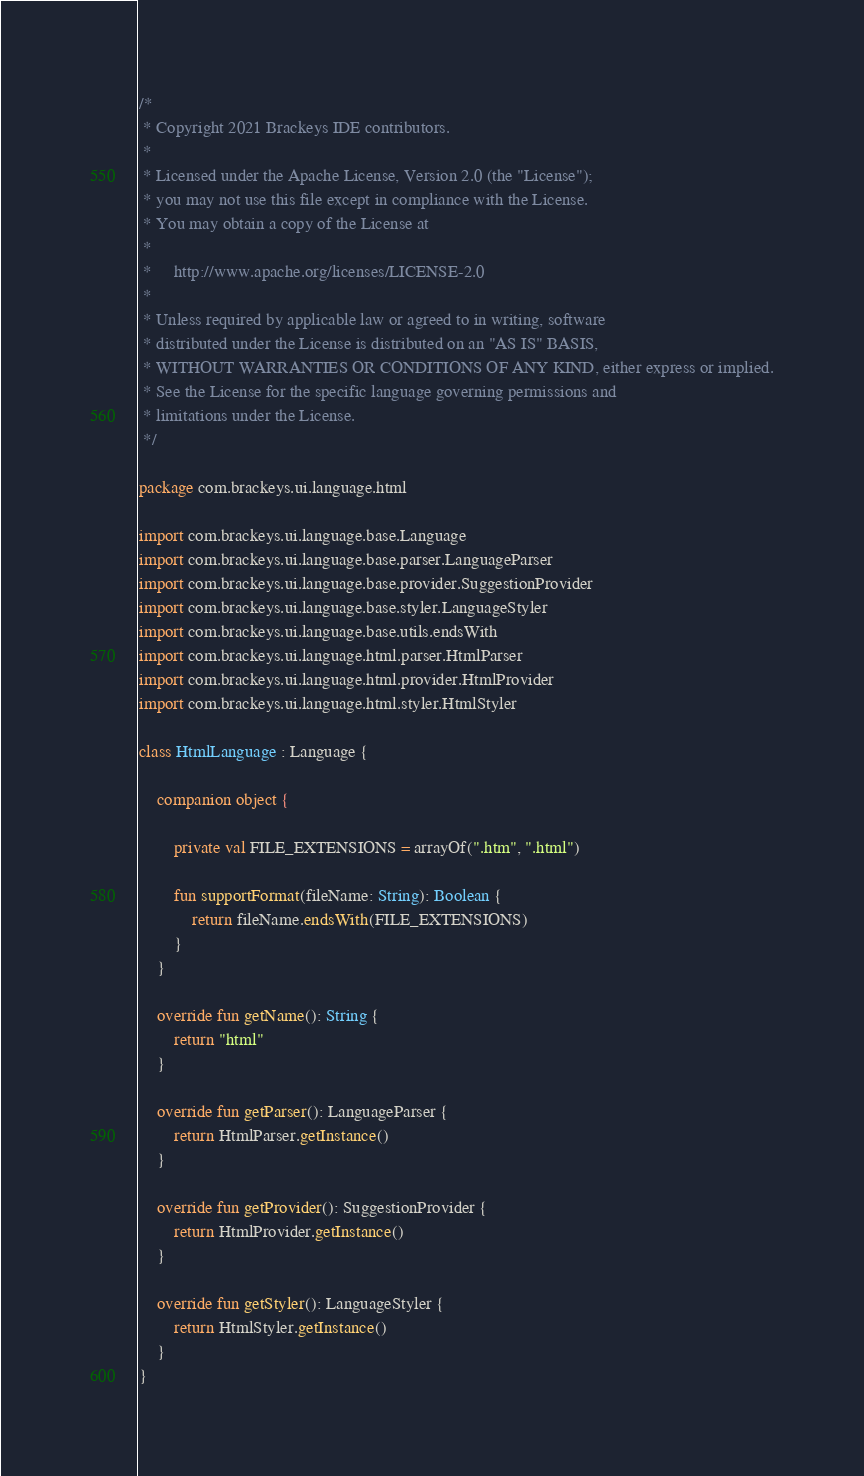Convert code to text. <code><loc_0><loc_0><loc_500><loc_500><_Kotlin_>/*
 * Copyright 2021 Brackeys IDE contributors.
 *
 * Licensed under the Apache License, Version 2.0 (the "License");
 * you may not use this file except in compliance with the License.
 * You may obtain a copy of the License at
 *
 *     http://www.apache.org/licenses/LICENSE-2.0
 *
 * Unless required by applicable law or agreed to in writing, software
 * distributed under the License is distributed on an "AS IS" BASIS,
 * WITHOUT WARRANTIES OR CONDITIONS OF ANY KIND, either express or implied.
 * See the License for the specific language governing permissions and
 * limitations under the License.
 */

package com.brackeys.ui.language.html

import com.brackeys.ui.language.base.Language
import com.brackeys.ui.language.base.parser.LanguageParser
import com.brackeys.ui.language.base.provider.SuggestionProvider
import com.brackeys.ui.language.base.styler.LanguageStyler
import com.brackeys.ui.language.base.utils.endsWith
import com.brackeys.ui.language.html.parser.HtmlParser
import com.brackeys.ui.language.html.provider.HtmlProvider
import com.brackeys.ui.language.html.styler.HtmlStyler

class HtmlLanguage : Language {

    companion object {

        private val FILE_EXTENSIONS = arrayOf(".htm", ".html")

        fun supportFormat(fileName: String): Boolean {
            return fileName.endsWith(FILE_EXTENSIONS)
        }
    }

    override fun getName(): String {
        return "html"
    }

    override fun getParser(): LanguageParser {
        return HtmlParser.getInstance()
    }

    override fun getProvider(): SuggestionProvider {
        return HtmlProvider.getInstance()
    }

    override fun getStyler(): LanguageStyler {
        return HtmlStyler.getInstance()
    }
}</code> 